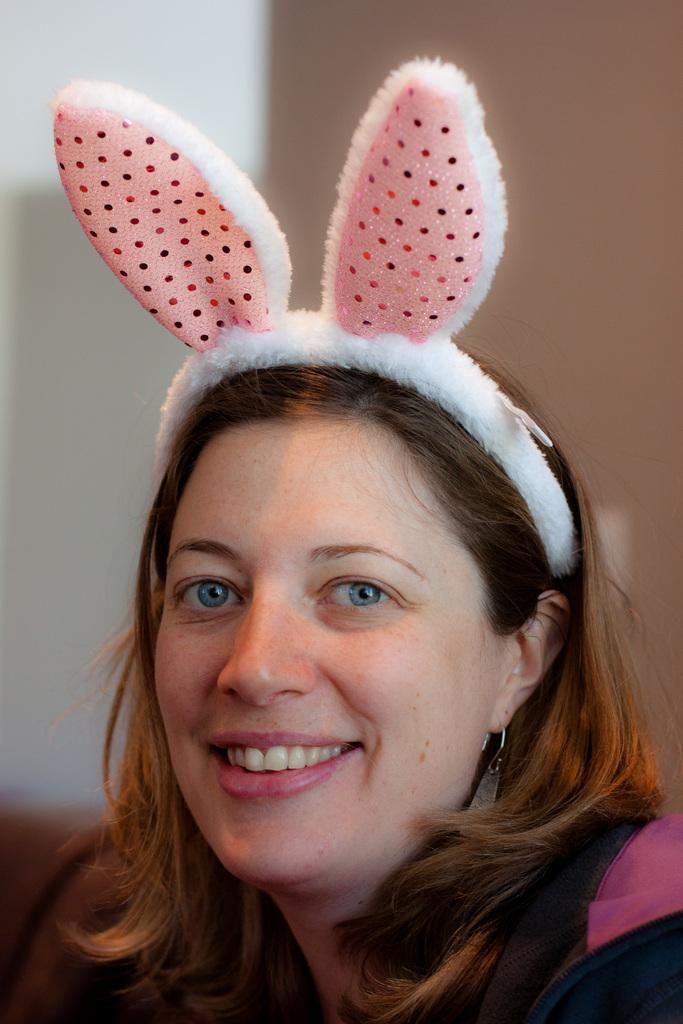Can you describe this image briefly? In this image we can see a lady wearing a bunny hat, and she is smiling, there is a wall, and the background is blurred. 